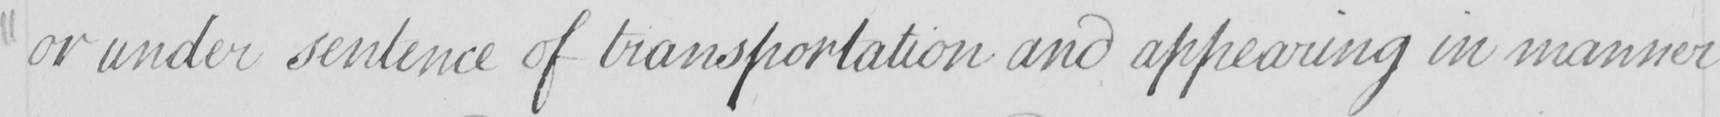Can you read and transcribe this handwriting? or under sentence of transportation and appearing in manner 